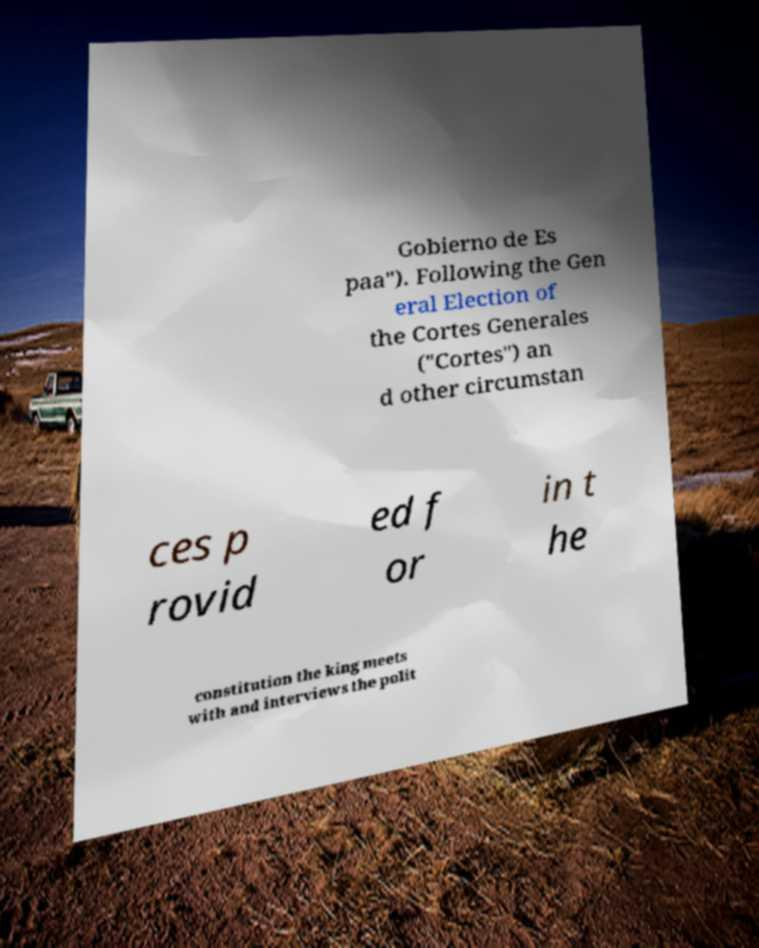Can you accurately transcribe the text from the provided image for me? Gobierno de Es paa"). Following the Gen eral Election of the Cortes Generales ("Cortes") an d other circumstan ces p rovid ed f or in t he constitution the king meets with and interviews the polit 